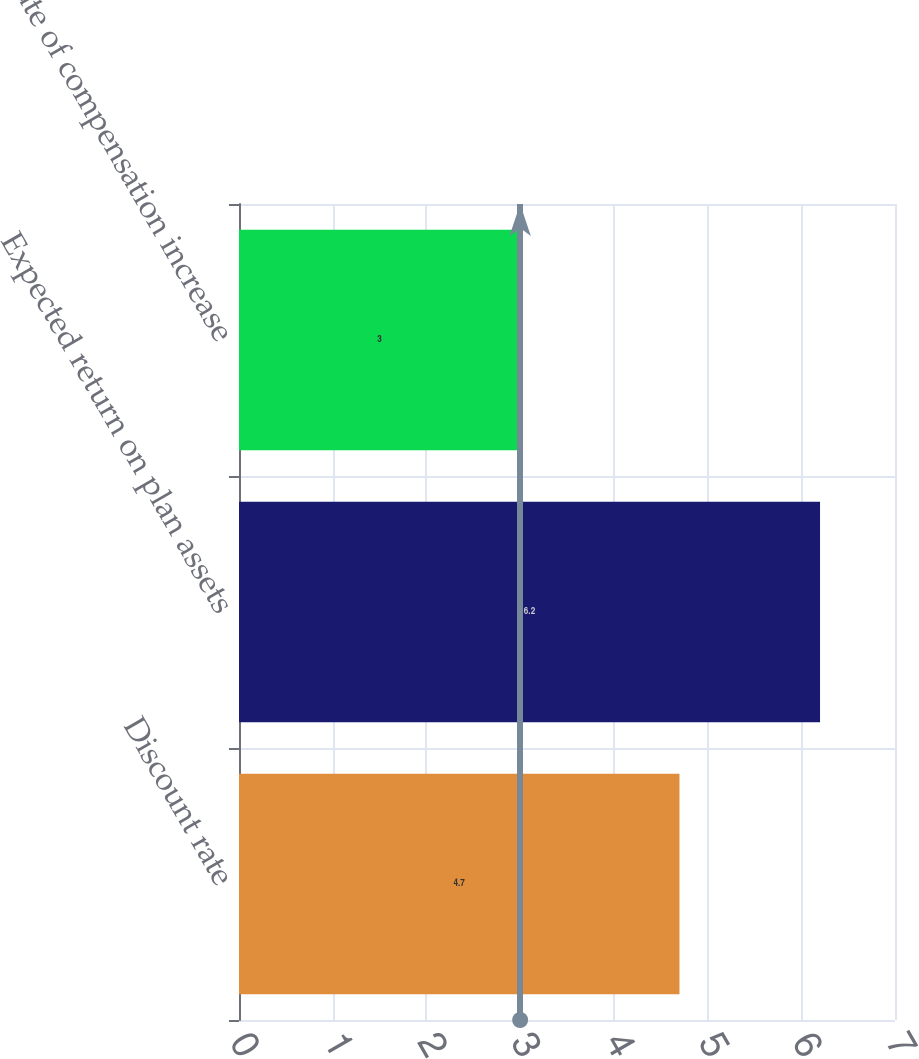Convert chart. <chart><loc_0><loc_0><loc_500><loc_500><bar_chart><fcel>Discount rate<fcel>Expected return on plan assets<fcel>Rate of compensation increase<nl><fcel>4.7<fcel>6.2<fcel>3<nl></chart> 